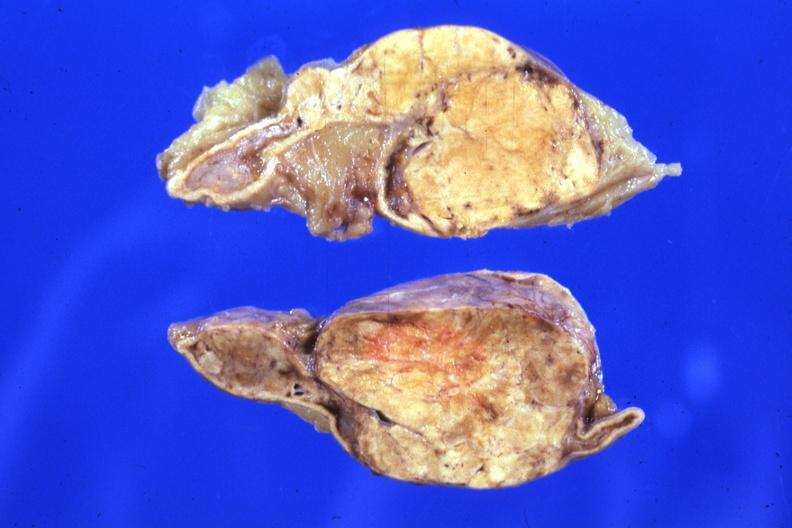what is present?
Answer the question using a single word or phrase. Cortical nodule 